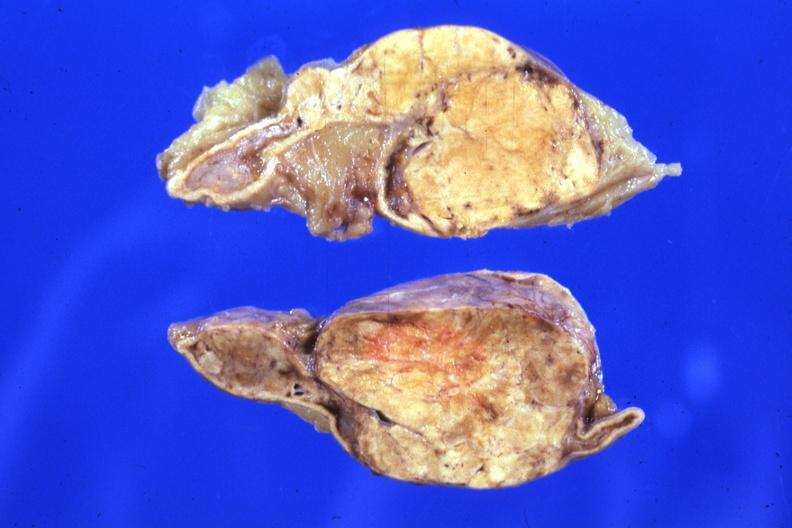what is present?
Answer the question using a single word or phrase. Cortical nodule 